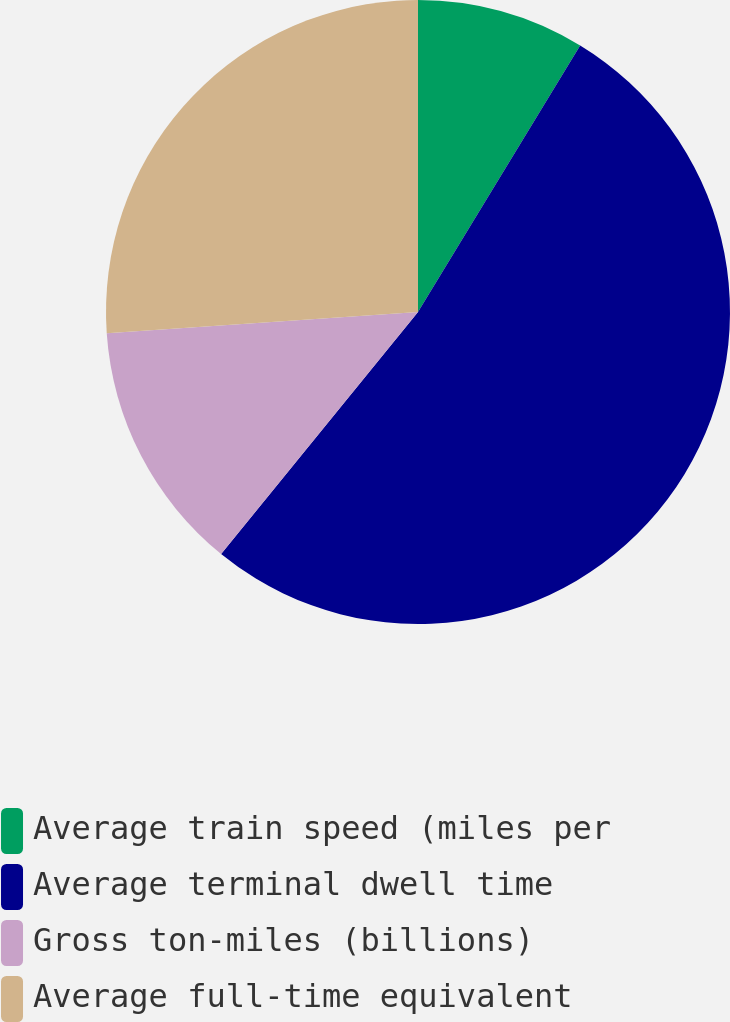Convert chart to OTSL. <chart><loc_0><loc_0><loc_500><loc_500><pie_chart><fcel>Average train speed (miles per<fcel>Average terminal dwell time<fcel>Gross ton-miles (billions)<fcel>Average full-time equivalent<nl><fcel>8.7%<fcel>52.17%<fcel>13.04%<fcel>26.09%<nl></chart> 